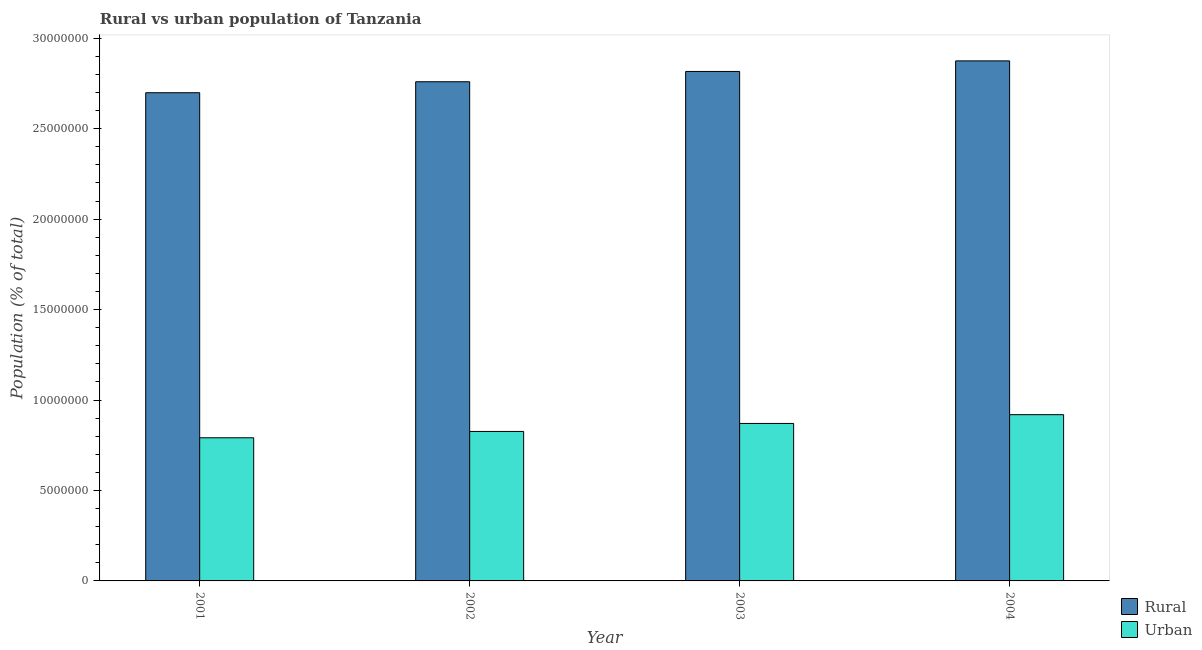How many groups of bars are there?
Give a very brief answer. 4. What is the label of the 3rd group of bars from the left?
Provide a short and direct response. 2003. In how many cases, is the number of bars for a given year not equal to the number of legend labels?
Your answer should be compact. 0. What is the rural population density in 2002?
Ensure brevity in your answer.  2.76e+07. Across all years, what is the maximum urban population density?
Offer a terse response. 9.19e+06. Across all years, what is the minimum urban population density?
Provide a succinct answer. 7.91e+06. In which year was the rural population density minimum?
Ensure brevity in your answer.  2001. What is the total rural population density in the graph?
Give a very brief answer. 1.11e+08. What is the difference between the urban population density in 2001 and that in 2004?
Your answer should be very brief. -1.28e+06. What is the difference between the urban population density in 2001 and the rural population density in 2002?
Give a very brief answer. -3.50e+05. What is the average urban population density per year?
Provide a short and direct response. 8.52e+06. In the year 2003, what is the difference between the rural population density and urban population density?
Your response must be concise. 0. In how many years, is the urban population density greater than 6000000 %?
Your answer should be compact. 4. What is the ratio of the rural population density in 2001 to that in 2002?
Make the answer very short. 0.98. Is the urban population density in 2001 less than that in 2003?
Offer a very short reply. Yes. Is the difference between the rural population density in 2001 and 2004 greater than the difference between the urban population density in 2001 and 2004?
Keep it short and to the point. No. What is the difference between the highest and the second highest rural population density?
Provide a short and direct response. 5.85e+05. What is the difference between the highest and the lowest urban population density?
Your answer should be compact. 1.28e+06. In how many years, is the urban population density greater than the average urban population density taken over all years?
Your answer should be compact. 2. What does the 1st bar from the left in 2003 represents?
Offer a very short reply. Rural. What does the 2nd bar from the right in 2004 represents?
Your response must be concise. Rural. How many bars are there?
Keep it short and to the point. 8. How many years are there in the graph?
Offer a very short reply. 4. What is the difference between two consecutive major ticks on the Y-axis?
Your answer should be very brief. 5.00e+06. Are the values on the major ticks of Y-axis written in scientific E-notation?
Your response must be concise. No. Does the graph contain grids?
Keep it short and to the point. No. Where does the legend appear in the graph?
Offer a terse response. Bottom right. How many legend labels are there?
Offer a terse response. 2. What is the title of the graph?
Your response must be concise. Rural vs urban population of Tanzania. Does "International Tourists" appear as one of the legend labels in the graph?
Give a very brief answer. No. What is the label or title of the X-axis?
Your response must be concise. Year. What is the label or title of the Y-axis?
Give a very brief answer. Population (% of total). What is the Population (% of total) of Rural in 2001?
Give a very brief answer. 2.70e+07. What is the Population (% of total) of Urban in 2001?
Make the answer very short. 7.91e+06. What is the Population (% of total) of Rural in 2002?
Give a very brief answer. 2.76e+07. What is the Population (% of total) in Urban in 2002?
Offer a terse response. 8.26e+06. What is the Population (% of total) in Rural in 2003?
Provide a short and direct response. 2.82e+07. What is the Population (% of total) of Urban in 2003?
Ensure brevity in your answer.  8.70e+06. What is the Population (% of total) of Rural in 2004?
Your response must be concise. 2.87e+07. What is the Population (% of total) of Urban in 2004?
Give a very brief answer. 9.19e+06. Across all years, what is the maximum Population (% of total) of Rural?
Offer a very short reply. 2.87e+07. Across all years, what is the maximum Population (% of total) in Urban?
Give a very brief answer. 9.19e+06. Across all years, what is the minimum Population (% of total) in Rural?
Your response must be concise. 2.70e+07. Across all years, what is the minimum Population (% of total) of Urban?
Offer a very short reply. 7.91e+06. What is the total Population (% of total) of Rural in the graph?
Your response must be concise. 1.11e+08. What is the total Population (% of total) in Urban in the graph?
Keep it short and to the point. 3.41e+07. What is the difference between the Population (% of total) of Rural in 2001 and that in 2002?
Provide a short and direct response. -6.07e+05. What is the difference between the Population (% of total) of Urban in 2001 and that in 2002?
Give a very brief answer. -3.50e+05. What is the difference between the Population (% of total) of Rural in 2001 and that in 2003?
Make the answer very short. -1.18e+06. What is the difference between the Population (% of total) of Urban in 2001 and that in 2003?
Make the answer very short. -7.91e+05. What is the difference between the Population (% of total) of Rural in 2001 and that in 2004?
Provide a short and direct response. -1.76e+06. What is the difference between the Population (% of total) in Urban in 2001 and that in 2004?
Offer a terse response. -1.28e+06. What is the difference between the Population (% of total) of Rural in 2002 and that in 2003?
Give a very brief answer. -5.69e+05. What is the difference between the Population (% of total) in Urban in 2002 and that in 2003?
Offer a very short reply. -4.42e+05. What is the difference between the Population (% of total) in Rural in 2002 and that in 2004?
Your answer should be compact. -1.15e+06. What is the difference between the Population (% of total) of Urban in 2002 and that in 2004?
Your response must be concise. -9.27e+05. What is the difference between the Population (% of total) in Rural in 2003 and that in 2004?
Make the answer very short. -5.85e+05. What is the difference between the Population (% of total) of Urban in 2003 and that in 2004?
Your answer should be compact. -4.85e+05. What is the difference between the Population (% of total) of Rural in 2001 and the Population (% of total) of Urban in 2002?
Provide a succinct answer. 1.87e+07. What is the difference between the Population (% of total) of Rural in 2001 and the Population (% of total) of Urban in 2003?
Make the answer very short. 1.83e+07. What is the difference between the Population (% of total) of Rural in 2001 and the Population (% of total) of Urban in 2004?
Your answer should be very brief. 1.78e+07. What is the difference between the Population (% of total) in Rural in 2002 and the Population (% of total) in Urban in 2003?
Offer a very short reply. 1.89e+07. What is the difference between the Population (% of total) of Rural in 2002 and the Population (% of total) of Urban in 2004?
Provide a succinct answer. 1.84e+07. What is the difference between the Population (% of total) in Rural in 2003 and the Population (% of total) in Urban in 2004?
Your answer should be compact. 1.90e+07. What is the average Population (% of total) of Rural per year?
Your answer should be compact. 2.79e+07. What is the average Population (% of total) in Urban per year?
Your answer should be very brief. 8.52e+06. In the year 2001, what is the difference between the Population (% of total) in Rural and Population (% of total) in Urban?
Give a very brief answer. 1.91e+07. In the year 2002, what is the difference between the Population (% of total) in Rural and Population (% of total) in Urban?
Ensure brevity in your answer.  1.93e+07. In the year 2003, what is the difference between the Population (% of total) of Rural and Population (% of total) of Urban?
Your response must be concise. 1.95e+07. In the year 2004, what is the difference between the Population (% of total) of Rural and Population (% of total) of Urban?
Your response must be concise. 1.96e+07. What is the ratio of the Population (% of total) in Rural in 2001 to that in 2002?
Make the answer very short. 0.98. What is the ratio of the Population (% of total) of Urban in 2001 to that in 2002?
Your answer should be very brief. 0.96. What is the ratio of the Population (% of total) of Urban in 2001 to that in 2003?
Offer a terse response. 0.91. What is the ratio of the Population (% of total) in Rural in 2001 to that in 2004?
Offer a terse response. 0.94. What is the ratio of the Population (% of total) in Urban in 2001 to that in 2004?
Your answer should be compact. 0.86. What is the ratio of the Population (% of total) in Rural in 2002 to that in 2003?
Your answer should be very brief. 0.98. What is the ratio of the Population (% of total) of Urban in 2002 to that in 2003?
Offer a very short reply. 0.95. What is the ratio of the Population (% of total) in Rural in 2002 to that in 2004?
Give a very brief answer. 0.96. What is the ratio of the Population (% of total) of Urban in 2002 to that in 2004?
Keep it short and to the point. 0.9. What is the ratio of the Population (% of total) in Rural in 2003 to that in 2004?
Offer a terse response. 0.98. What is the ratio of the Population (% of total) of Urban in 2003 to that in 2004?
Your answer should be very brief. 0.95. What is the difference between the highest and the second highest Population (% of total) in Rural?
Offer a very short reply. 5.85e+05. What is the difference between the highest and the second highest Population (% of total) of Urban?
Provide a short and direct response. 4.85e+05. What is the difference between the highest and the lowest Population (% of total) in Rural?
Provide a succinct answer. 1.76e+06. What is the difference between the highest and the lowest Population (% of total) of Urban?
Ensure brevity in your answer.  1.28e+06. 